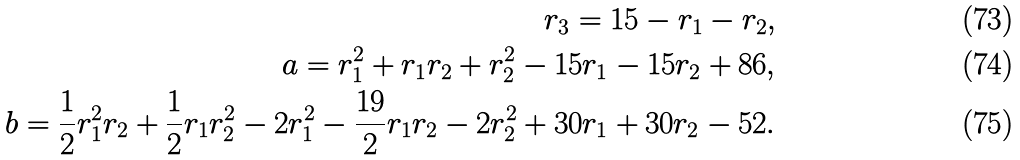Convert formula to latex. <formula><loc_0><loc_0><loc_500><loc_500>r _ { 3 } = 1 5 - r _ { 1 } - r _ { 2 } , \\ a = r _ { 1 } ^ { 2 } + r _ { 1 } r _ { 2 } + r _ { 2 } ^ { 2 } - 1 5 r _ { 1 } - 1 5 r _ { 2 } + 8 6 , \\ b = \frac { 1 } { 2 } r _ { 1 } ^ { 2 } r _ { 2 } + \frac { 1 } { 2 } r _ { 1 } r _ { 2 } ^ { 2 } - 2 r _ { 1 } ^ { 2 } - \frac { 1 9 } { 2 } r _ { 1 } r _ { 2 } - 2 r _ { 2 } ^ { 2 } + 3 0 r _ { 1 } + 3 0 r _ { 2 } - 5 2 .</formula> 